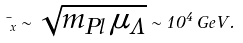Convert formula to latex. <formula><loc_0><loc_0><loc_500><loc_500>\mu _ { x } \sim \sqrt { m _ { P l } \, \mu _ { \Lambda } } \sim 1 0 ^ { 4 } \, G e V .</formula> 